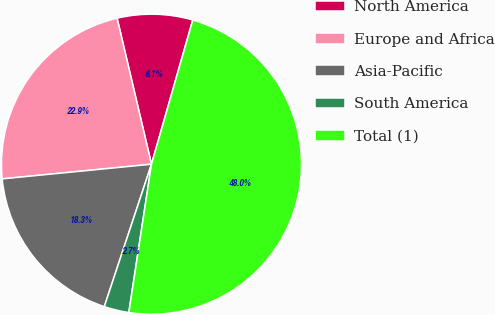Convert chart. <chart><loc_0><loc_0><loc_500><loc_500><pie_chart><fcel>North America<fcel>Europe and Africa<fcel>Asia-Pacific<fcel>South America<fcel>Total (1)<nl><fcel>8.12%<fcel>22.88%<fcel>18.35%<fcel>2.68%<fcel>47.98%<nl></chart> 